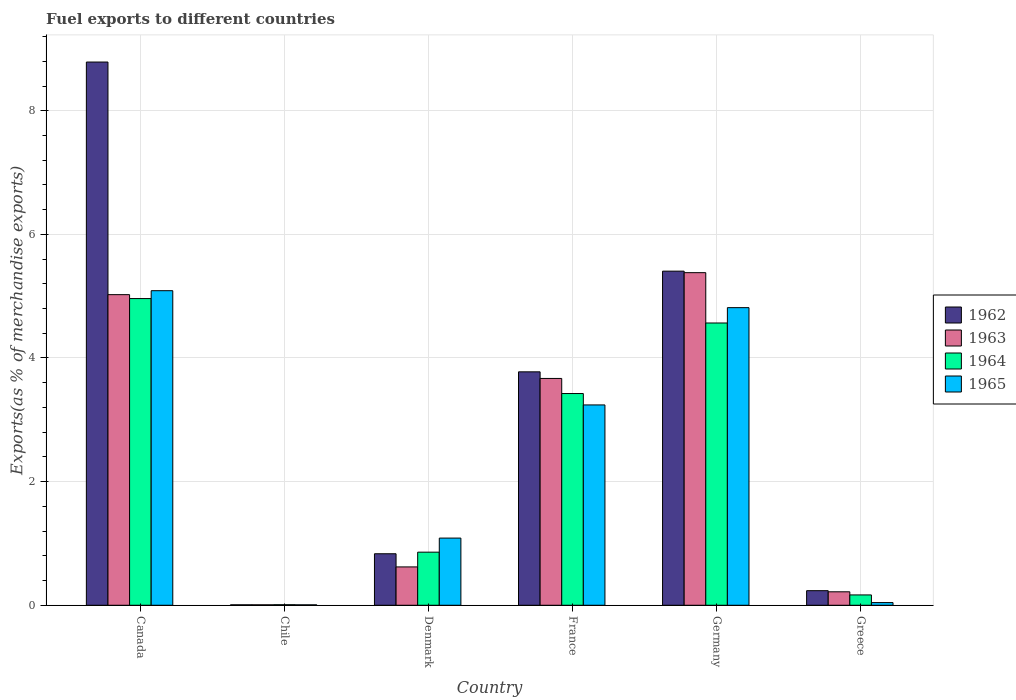How many groups of bars are there?
Keep it short and to the point. 6. Are the number of bars per tick equal to the number of legend labels?
Ensure brevity in your answer.  Yes. How many bars are there on the 1st tick from the left?
Provide a short and direct response. 4. What is the label of the 4th group of bars from the left?
Keep it short and to the point. France. In how many cases, is the number of bars for a given country not equal to the number of legend labels?
Your response must be concise. 0. What is the percentage of exports to different countries in 1965 in France?
Your answer should be compact. 3.24. Across all countries, what is the maximum percentage of exports to different countries in 1965?
Make the answer very short. 5.09. Across all countries, what is the minimum percentage of exports to different countries in 1963?
Offer a very short reply. 0.01. What is the total percentage of exports to different countries in 1964 in the graph?
Make the answer very short. 13.99. What is the difference between the percentage of exports to different countries in 1962 in Chile and that in Denmark?
Make the answer very short. -0.83. What is the difference between the percentage of exports to different countries in 1963 in Greece and the percentage of exports to different countries in 1965 in France?
Provide a succinct answer. -3.02. What is the average percentage of exports to different countries in 1965 per country?
Make the answer very short. 2.38. What is the difference between the percentage of exports to different countries of/in 1963 and percentage of exports to different countries of/in 1965 in Germany?
Make the answer very short. 0.57. In how many countries, is the percentage of exports to different countries in 1964 greater than 4.8 %?
Keep it short and to the point. 1. What is the ratio of the percentage of exports to different countries in 1964 in Canada to that in Chile?
Provide a succinct answer. 555.45. Is the percentage of exports to different countries in 1962 in Canada less than that in Chile?
Make the answer very short. No. Is the difference between the percentage of exports to different countries in 1963 in France and Germany greater than the difference between the percentage of exports to different countries in 1965 in France and Germany?
Make the answer very short. No. What is the difference between the highest and the second highest percentage of exports to different countries in 1962?
Give a very brief answer. 5.01. What is the difference between the highest and the lowest percentage of exports to different countries in 1965?
Keep it short and to the point. 5.08. What does the 4th bar from the left in Chile represents?
Ensure brevity in your answer.  1965. What does the 3rd bar from the right in Greece represents?
Offer a very short reply. 1963. Is it the case that in every country, the sum of the percentage of exports to different countries in 1962 and percentage of exports to different countries in 1964 is greater than the percentage of exports to different countries in 1963?
Offer a very short reply. Yes. How many bars are there?
Provide a short and direct response. 24. Are all the bars in the graph horizontal?
Give a very brief answer. No. How many countries are there in the graph?
Provide a short and direct response. 6. What is the difference between two consecutive major ticks on the Y-axis?
Ensure brevity in your answer.  2. Does the graph contain any zero values?
Give a very brief answer. No. Where does the legend appear in the graph?
Provide a succinct answer. Center right. How are the legend labels stacked?
Keep it short and to the point. Vertical. What is the title of the graph?
Offer a terse response. Fuel exports to different countries. Does "1997" appear as one of the legend labels in the graph?
Ensure brevity in your answer.  No. What is the label or title of the Y-axis?
Offer a terse response. Exports(as % of merchandise exports). What is the Exports(as % of merchandise exports) of 1962 in Canada?
Provide a succinct answer. 8.79. What is the Exports(as % of merchandise exports) of 1963 in Canada?
Your answer should be compact. 5.02. What is the Exports(as % of merchandise exports) of 1964 in Canada?
Ensure brevity in your answer.  4.96. What is the Exports(as % of merchandise exports) of 1965 in Canada?
Make the answer very short. 5.09. What is the Exports(as % of merchandise exports) of 1962 in Chile?
Your answer should be compact. 0.01. What is the Exports(as % of merchandise exports) of 1963 in Chile?
Offer a terse response. 0.01. What is the Exports(as % of merchandise exports) in 1964 in Chile?
Your answer should be very brief. 0.01. What is the Exports(as % of merchandise exports) in 1965 in Chile?
Your response must be concise. 0.01. What is the Exports(as % of merchandise exports) of 1962 in Denmark?
Your answer should be compact. 0.83. What is the Exports(as % of merchandise exports) of 1963 in Denmark?
Give a very brief answer. 0.62. What is the Exports(as % of merchandise exports) in 1964 in Denmark?
Make the answer very short. 0.86. What is the Exports(as % of merchandise exports) of 1965 in Denmark?
Your answer should be very brief. 1.09. What is the Exports(as % of merchandise exports) in 1962 in France?
Keep it short and to the point. 3.78. What is the Exports(as % of merchandise exports) of 1963 in France?
Your answer should be very brief. 3.67. What is the Exports(as % of merchandise exports) of 1964 in France?
Offer a very short reply. 3.43. What is the Exports(as % of merchandise exports) of 1965 in France?
Offer a terse response. 3.24. What is the Exports(as % of merchandise exports) in 1962 in Germany?
Your response must be concise. 5.4. What is the Exports(as % of merchandise exports) of 1963 in Germany?
Your response must be concise. 5.38. What is the Exports(as % of merchandise exports) of 1964 in Germany?
Your response must be concise. 4.57. What is the Exports(as % of merchandise exports) in 1965 in Germany?
Offer a terse response. 4.81. What is the Exports(as % of merchandise exports) of 1962 in Greece?
Offer a very short reply. 0.24. What is the Exports(as % of merchandise exports) of 1963 in Greece?
Your response must be concise. 0.22. What is the Exports(as % of merchandise exports) in 1964 in Greece?
Your answer should be compact. 0.17. What is the Exports(as % of merchandise exports) in 1965 in Greece?
Ensure brevity in your answer.  0.04. Across all countries, what is the maximum Exports(as % of merchandise exports) in 1962?
Offer a very short reply. 8.79. Across all countries, what is the maximum Exports(as % of merchandise exports) of 1963?
Your response must be concise. 5.38. Across all countries, what is the maximum Exports(as % of merchandise exports) of 1964?
Offer a very short reply. 4.96. Across all countries, what is the maximum Exports(as % of merchandise exports) of 1965?
Provide a succinct answer. 5.09. Across all countries, what is the minimum Exports(as % of merchandise exports) of 1962?
Provide a succinct answer. 0.01. Across all countries, what is the minimum Exports(as % of merchandise exports) of 1963?
Provide a succinct answer. 0.01. Across all countries, what is the minimum Exports(as % of merchandise exports) in 1964?
Ensure brevity in your answer.  0.01. Across all countries, what is the minimum Exports(as % of merchandise exports) of 1965?
Offer a terse response. 0.01. What is the total Exports(as % of merchandise exports) in 1962 in the graph?
Ensure brevity in your answer.  19.05. What is the total Exports(as % of merchandise exports) of 1963 in the graph?
Keep it short and to the point. 14.92. What is the total Exports(as % of merchandise exports) of 1964 in the graph?
Give a very brief answer. 13.99. What is the total Exports(as % of merchandise exports) of 1965 in the graph?
Offer a very short reply. 14.28. What is the difference between the Exports(as % of merchandise exports) in 1962 in Canada and that in Chile?
Your answer should be compact. 8.78. What is the difference between the Exports(as % of merchandise exports) of 1963 in Canada and that in Chile?
Your response must be concise. 5.02. What is the difference between the Exports(as % of merchandise exports) of 1964 in Canada and that in Chile?
Keep it short and to the point. 4.95. What is the difference between the Exports(as % of merchandise exports) in 1965 in Canada and that in Chile?
Offer a very short reply. 5.08. What is the difference between the Exports(as % of merchandise exports) of 1962 in Canada and that in Denmark?
Keep it short and to the point. 7.95. What is the difference between the Exports(as % of merchandise exports) of 1963 in Canada and that in Denmark?
Provide a short and direct response. 4.4. What is the difference between the Exports(as % of merchandise exports) of 1964 in Canada and that in Denmark?
Offer a terse response. 4.1. What is the difference between the Exports(as % of merchandise exports) in 1965 in Canada and that in Denmark?
Your answer should be very brief. 4. What is the difference between the Exports(as % of merchandise exports) in 1962 in Canada and that in France?
Offer a very short reply. 5.01. What is the difference between the Exports(as % of merchandise exports) in 1963 in Canada and that in France?
Your answer should be very brief. 1.36. What is the difference between the Exports(as % of merchandise exports) in 1964 in Canada and that in France?
Provide a succinct answer. 1.54. What is the difference between the Exports(as % of merchandise exports) of 1965 in Canada and that in France?
Provide a succinct answer. 1.85. What is the difference between the Exports(as % of merchandise exports) of 1962 in Canada and that in Germany?
Provide a succinct answer. 3.38. What is the difference between the Exports(as % of merchandise exports) of 1963 in Canada and that in Germany?
Your answer should be compact. -0.36. What is the difference between the Exports(as % of merchandise exports) of 1964 in Canada and that in Germany?
Your response must be concise. 0.4. What is the difference between the Exports(as % of merchandise exports) in 1965 in Canada and that in Germany?
Provide a succinct answer. 0.27. What is the difference between the Exports(as % of merchandise exports) of 1962 in Canada and that in Greece?
Provide a short and direct response. 8.55. What is the difference between the Exports(as % of merchandise exports) in 1963 in Canada and that in Greece?
Keep it short and to the point. 4.81. What is the difference between the Exports(as % of merchandise exports) of 1964 in Canada and that in Greece?
Offer a very short reply. 4.79. What is the difference between the Exports(as % of merchandise exports) in 1965 in Canada and that in Greece?
Your response must be concise. 5.05. What is the difference between the Exports(as % of merchandise exports) in 1962 in Chile and that in Denmark?
Make the answer very short. -0.83. What is the difference between the Exports(as % of merchandise exports) in 1963 in Chile and that in Denmark?
Provide a succinct answer. -0.61. What is the difference between the Exports(as % of merchandise exports) of 1964 in Chile and that in Denmark?
Your response must be concise. -0.85. What is the difference between the Exports(as % of merchandise exports) in 1965 in Chile and that in Denmark?
Ensure brevity in your answer.  -1.08. What is the difference between the Exports(as % of merchandise exports) of 1962 in Chile and that in France?
Your answer should be compact. -3.77. What is the difference between the Exports(as % of merchandise exports) of 1963 in Chile and that in France?
Offer a very short reply. -3.66. What is the difference between the Exports(as % of merchandise exports) of 1964 in Chile and that in France?
Provide a short and direct response. -3.42. What is the difference between the Exports(as % of merchandise exports) of 1965 in Chile and that in France?
Provide a short and direct response. -3.23. What is the difference between the Exports(as % of merchandise exports) of 1962 in Chile and that in Germany?
Offer a terse response. -5.4. What is the difference between the Exports(as % of merchandise exports) in 1963 in Chile and that in Germany?
Your response must be concise. -5.37. What is the difference between the Exports(as % of merchandise exports) in 1964 in Chile and that in Germany?
Offer a very short reply. -4.56. What is the difference between the Exports(as % of merchandise exports) in 1965 in Chile and that in Germany?
Ensure brevity in your answer.  -4.81. What is the difference between the Exports(as % of merchandise exports) in 1962 in Chile and that in Greece?
Give a very brief answer. -0.23. What is the difference between the Exports(as % of merchandise exports) in 1963 in Chile and that in Greece?
Offer a terse response. -0.21. What is the difference between the Exports(as % of merchandise exports) of 1964 in Chile and that in Greece?
Keep it short and to the point. -0.16. What is the difference between the Exports(as % of merchandise exports) of 1965 in Chile and that in Greece?
Give a very brief answer. -0.04. What is the difference between the Exports(as % of merchandise exports) of 1962 in Denmark and that in France?
Offer a terse response. -2.94. What is the difference between the Exports(as % of merchandise exports) of 1963 in Denmark and that in France?
Provide a succinct answer. -3.05. What is the difference between the Exports(as % of merchandise exports) of 1964 in Denmark and that in France?
Provide a short and direct response. -2.57. What is the difference between the Exports(as % of merchandise exports) in 1965 in Denmark and that in France?
Offer a terse response. -2.15. What is the difference between the Exports(as % of merchandise exports) in 1962 in Denmark and that in Germany?
Make the answer very short. -4.57. What is the difference between the Exports(as % of merchandise exports) in 1963 in Denmark and that in Germany?
Keep it short and to the point. -4.76. What is the difference between the Exports(as % of merchandise exports) of 1964 in Denmark and that in Germany?
Make the answer very short. -3.71. What is the difference between the Exports(as % of merchandise exports) of 1965 in Denmark and that in Germany?
Your answer should be compact. -3.73. What is the difference between the Exports(as % of merchandise exports) in 1962 in Denmark and that in Greece?
Your response must be concise. 0.6. What is the difference between the Exports(as % of merchandise exports) of 1963 in Denmark and that in Greece?
Give a very brief answer. 0.4. What is the difference between the Exports(as % of merchandise exports) of 1964 in Denmark and that in Greece?
Your answer should be very brief. 0.69. What is the difference between the Exports(as % of merchandise exports) in 1965 in Denmark and that in Greece?
Keep it short and to the point. 1.04. What is the difference between the Exports(as % of merchandise exports) of 1962 in France and that in Germany?
Keep it short and to the point. -1.63. What is the difference between the Exports(as % of merchandise exports) of 1963 in France and that in Germany?
Give a very brief answer. -1.71. What is the difference between the Exports(as % of merchandise exports) in 1964 in France and that in Germany?
Your answer should be very brief. -1.14. What is the difference between the Exports(as % of merchandise exports) in 1965 in France and that in Germany?
Keep it short and to the point. -1.57. What is the difference between the Exports(as % of merchandise exports) in 1962 in France and that in Greece?
Your answer should be compact. 3.54. What is the difference between the Exports(as % of merchandise exports) in 1963 in France and that in Greece?
Your answer should be compact. 3.45. What is the difference between the Exports(as % of merchandise exports) in 1964 in France and that in Greece?
Provide a succinct answer. 3.26. What is the difference between the Exports(as % of merchandise exports) of 1965 in France and that in Greece?
Provide a succinct answer. 3.2. What is the difference between the Exports(as % of merchandise exports) in 1962 in Germany and that in Greece?
Provide a succinct answer. 5.17. What is the difference between the Exports(as % of merchandise exports) in 1963 in Germany and that in Greece?
Give a very brief answer. 5.16. What is the difference between the Exports(as % of merchandise exports) in 1964 in Germany and that in Greece?
Make the answer very short. 4.4. What is the difference between the Exports(as % of merchandise exports) of 1965 in Germany and that in Greece?
Your response must be concise. 4.77. What is the difference between the Exports(as % of merchandise exports) in 1962 in Canada and the Exports(as % of merchandise exports) in 1963 in Chile?
Offer a terse response. 8.78. What is the difference between the Exports(as % of merchandise exports) of 1962 in Canada and the Exports(as % of merchandise exports) of 1964 in Chile?
Your answer should be compact. 8.78. What is the difference between the Exports(as % of merchandise exports) in 1962 in Canada and the Exports(as % of merchandise exports) in 1965 in Chile?
Offer a terse response. 8.78. What is the difference between the Exports(as % of merchandise exports) in 1963 in Canada and the Exports(as % of merchandise exports) in 1964 in Chile?
Provide a succinct answer. 5.02. What is the difference between the Exports(as % of merchandise exports) in 1963 in Canada and the Exports(as % of merchandise exports) in 1965 in Chile?
Give a very brief answer. 5.02. What is the difference between the Exports(as % of merchandise exports) of 1964 in Canada and the Exports(as % of merchandise exports) of 1965 in Chile?
Provide a succinct answer. 4.95. What is the difference between the Exports(as % of merchandise exports) in 1962 in Canada and the Exports(as % of merchandise exports) in 1963 in Denmark?
Ensure brevity in your answer.  8.17. What is the difference between the Exports(as % of merchandise exports) of 1962 in Canada and the Exports(as % of merchandise exports) of 1964 in Denmark?
Your response must be concise. 7.93. What is the difference between the Exports(as % of merchandise exports) of 1962 in Canada and the Exports(as % of merchandise exports) of 1965 in Denmark?
Your response must be concise. 7.7. What is the difference between the Exports(as % of merchandise exports) in 1963 in Canada and the Exports(as % of merchandise exports) in 1964 in Denmark?
Provide a short and direct response. 4.17. What is the difference between the Exports(as % of merchandise exports) in 1963 in Canada and the Exports(as % of merchandise exports) in 1965 in Denmark?
Provide a short and direct response. 3.94. What is the difference between the Exports(as % of merchandise exports) in 1964 in Canada and the Exports(as % of merchandise exports) in 1965 in Denmark?
Ensure brevity in your answer.  3.87. What is the difference between the Exports(as % of merchandise exports) in 1962 in Canada and the Exports(as % of merchandise exports) in 1963 in France?
Offer a terse response. 5.12. What is the difference between the Exports(as % of merchandise exports) in 1962 in Canada and the Exports(as % of merchandise exports) in 1964 in France?
Offer a terse response. 5.36. What is the difference between the Exports(as % of merchandise exports) of 1962 in Canada and the Exports(as % of merchandise exports) of 1965 in France?
Offer a very short reply. 5.55. What is the difference between the Exports(as % of merchandise exports) of 1963 in Canada and the Exports(as % of merchandise exports) of 1964 in France?
Provide a short and direct response. 1.6. What is the difference between the Exports(as % of merchandise exports) of 1963 in Canada and the Exports(as % of merchandise exports) of 1965 in France?
Provide a short and direct response. 1.78. What is the difference between the Exports(as % of merchandise exports) in 1964 in Canada and the Exports(as % of merchandise exports) in 1965 in France?
Ensure brevity in your answer.  1.72. What is the difference between the Exports(as % of merchandise exports) of 1962 in Canada and the Exports(as % of merchandise exports) of 1963 in Germany?
Offer a very short reply. 3.41. What is the difference between the Exports(as % of merchandise exports) of 1962 in Canada and the Exports(as % of merchandise exports) of 1964 in Germany?
Provide a short and direct response. 4.22. What is the difference between the Exports(as % of merchandise exports) in 1962 in Canada and the Exports(as % of merchandise exports) in 1965 in Germany?
Your answer should be very brief. 3.97. What is the difference between the Exports(as % of merchandise exports) of 1963 in Canada and the Exports(as % of merchandise exports) of 1964 in Germany?
Ensure brevity in your answer.  0.46. What is the difference between the Exports(as % of merchandise exports) of 1963 in Canada and the Exports(as % of merchandise exports) of 1965 in Germany?
Offer a very short reply. 0.21. What is the difference between the Exports(as % of merchandise exports) in 1964 in Canada and the Exports(as % of merchandise exports) in 1965 in Germany?
Give a very brief answer. 0.15. What is the difference between the Exports(as % of merchandise exports) of 1962 in Canada and the Exports(as % of merchandise exports) of 1963 in Greece?
Provide a short and direct response. 8.57. What is the difference between the Exports(as % of merchandise exports) of 1962 in Canada and the Exports(as % of merchandise exports) of 1964 in Greece?
Offer a terse response. 8.62. What is the difference between the Exports(as % of merchandise exports) in 1962 in Canada and the Exports(as % of merchandise exports) in 1965 in Greece?
Give a very brief answer. 8.74. What is the difference between the Exports(as % of merchandise exports) in 1963 in Canada and the Exports(as % of merchandise exports) in 1964 in Greece?
Offer a very short reply. 4.86. What is the difference between the Exports(as % of merchandise exports) in 1963 in Canada and the Exports(as % of merchandise exports) in 1965 in Greece?
Your answer should be very brief. 4.98. What is the difference between the Exports(as % of merchandise exports) of 1964 in Canada and the Exports(as % of merchandise exports) of 1965 in Greece?
Give a very brief answer. 4.92. What is the difference between the Exports(as % of merchandise exports) of 1962 in Chile and the Exports(as % of merchandise exports) of 1963 in Denmark?
Your answer should be compact. -0.61. What is the difference between the Exports(as % of merchandise exports) of 1962 in Chile and the Exports(as % of merchandise exports) of 1964 in Denmark?
Offer a terse response. -0.85. What is the difference between the Exports(as % of merchandise exports) in 1962 in Chile and the Exports(as % of merchandise exports) in 1965 in Denmark?
Your answer should be compact. -1.08. What is the difference between the Exports(as % of merchandise exports) of 1963 in Chile and the Exports(as % of merchandise exports) of 1964 in Denmark?
Provide a succinct answer. -0.85. What is the difference between the Exports(as % of merchandise exports) in 1963 in Chile and the Exports(as % of merchandise exports) in 1965 in Denmark?
Ensure brevity in your answer.  -1.08. What is the difference between the Exports(as % of merchandise exports) in 1964 in Chile and the Exports(as % of merchandise exports) in 1965 in Denmark?
Provide a succinct answer. -1.08. What is the difference between the Exports(as % of merchandise exports) of 1962 in Chile and the Exports(as % of merchandise exports) of 1963 in France?
Your response must be concise. -3.66. What is the difference between the Exports(as % of merchandise exports) in 1962 in Chile and the Exports(as % of merchandise exports) in 1964 in France?
Ensure brevity in your answer.  -3.42. What is the difference between the Exports(as % of merchandise exports) in 1962 in Chile and the Exports(as % of merchandise exports) in 1965 in France?
Your response must be concise. -3.23. What is the difference between the Exports(as % of merchandise exports) in 1963 in Chile and the Exports(as % of merchandise exports) in 1964 in France?
Your answer should be very brief. -3.42. What is the difference between the Exports(as % of merchandise exports) of 1963 in Chile and the Exports(as % of merchandise exports) of 1965 in France?
Offer a very short reply. -3.23. What is the difference between the Exports(as % of merchandise exports) of 1964 in Chile and the Exports(as % of merchandise exports) of 1965 in France?
Provide a short and direct response. -3.23. What is the difference between the Exports(as % of merchandise exports) in 1962 in Chile and the Exports(as % of merchandise exports) in 1963 in Germany?
Make the answer very short. -5.37. What is the difference between the Exports(as % of merchandise exports) of 1962 in Chile and the Exports(as % of merchandise exports) of 1964 in Germany?
Ensure brevity in your answer.  -4.56. What is the difference between the Exports(as % of merchandise exports) in 1962 in Chile and the Exports(as % of merchandise exports) in 1965 in Germany?
Make the answer very short. -4.81. What is the difference between the Exports(as % of merchandise exports) of 1963 in Chile and the Exports(as % of merchandise exports) of 1964 in Germany?
Ensure brevity in your answer.  -4.56. What is the difference between the Exports(as % of merchandise exports) in 1963 in Chile and the Exports(as % of merchandise exports) in 1965 in Germany?
Provide a short and direct response. -4.81. What is the difference between the Exports(as % of merchandise exports) of 1964 in Chile and the Exports(as % of merchandise exports) of 1965 in Germany?
Give a very brief answer. -4.81. What is the difference between the Exports(as % of merchandise exports) of 1962 in Chile and the Exports(as % of merchandise exports) of 1963 in Greece?
Provide a short and direct response. -0.21. What is the difference between the Exports(as % of merchandise exports) in 1962 in Chile and the Exports(as % of merchandise exports) in 1964 in Greece?
Provide a short and direct response. -0.16. What is the difference between the Exports(as % of merchandise exports) in 1962 in Chile and the Exports(as % of merchandise exports) in 1965 in Greece?
Give a very brief answer. -0.04. What is the difference between the Exports(as % of merchandise exports) in 1963 in Chile and the Exports(as % of merchandise exports) in 1964 in Greece?
Provide a succinct answer. -0.16. What is the difference between the Exports(as % of merchandise exports) in 1963 in Chile and the Exports(as % of merchandise exports) in 1965 in Greece?
Keep it short and to the point. -0.04. What is the difference between the Exports(as % of merchandise exports) of 1964 in Chile and the Exports(as % of merchandise exports) of 1965 in Greece?
Provide a short and direct response. -0.03. What is the difference between the Exports(as % of merchandise exports) in 1962 in Denmark and the Exports(as % of merchandise exports) in 1963 in France?
Keep it short and to the point. -2.84. What is the difference between the Exports(as % of merchandise exports) in 1962 in Denmark and the Exports(as % of merchandise exports) in 1964 in France?
Give a very brief answer. -2.59. What is the difference between the Exports(as % of merchandise exports) in 1962 in Denmark and the Exports(as % of merchandise exports) in 1965 in France?
Provide a succinct answer. -2.41. What is the difference between the Exports(as % of merchandise exports) of 1963 in Denmark and the Exports(as % of merchandise exports) of 1964 in France?
Offer a terse response. -2.8. What is the difference between the Exports(as % of merchandise exports) of 1963 in Denmark and the Exports(as % of merchandise exports) of 1965 in France?
Your answer should be compact. -2.62. What is the difference between the Exports(as % of merchandise exports) of 1964 in Denmark and the Exports(as % of merchandise exports) of 1965 in France?
Give a very brief answer. -2.38. What is the difference between the Exports(as % of merchandise exports) of 1962 in Denmark and the Exports(as % of merchandise exports) of 1963 in Germany?
Keep it short and to the point. -4.55. What is the difference between the Exports(as % of merchandise exports) of 1962 in Denmark and the Exports(as % of merchandise exports) of 1964 in Germany?
Your answer should be compact. -3.73. What is the difference between the Exports(as % of merchandise exports) in 1962 in Denmark and the Exports(as % of merchandise exports) in 1965 in Germany?
Your answer should be very brief. -3.98. What is the difference between the Exports(as % of merchandise exports) of 1963 in Denmark and the Exports(as % of merchandise exports) of 1964 in Germany?
Give a very brief answer. -3.95. What is the difference between the Exports(as % of merchandise exports) in 1963 in Denmark and the Exports(as % of merchandise exports) in 1965 in Germany?
Ensure brevity in your answer.  -4.19. What is the difference between the Exports(as % of merchandise exports) in 1964 in Denmark and the Exports(as % of merchandise exports) in 1965 in Germany?
Give a very brief answer. -3.96. What is the difference between the Exports(as % of merchandise exports) of 1962 in Denmark and the Exports(as % of merchandise exports) of 1963 in Greece?
Keep it short and to the point. 0.62. What is the difference between the Exports(as % of merchandise exports) in 1962 in Denmark and the Exports(as % of merchandise exports) in 1964 in Greece?
Your answer should be compact. 0.67. What is the difference between the Exports(as % of merchandise exports) in 1962 in Denmark and the Exports(as % of merchandise exports) in 1965 in Greece?
Ensure brevity in your answer.  0.79. What is the difference between the Exports(as % of merchandise exports) of 1963 in Denmark and the Exports(as % of merchandise exports) of 1964 in Greece?
Ensure brevity in your answer.  0.45. What is the difference between the Exports(as % of merchandise exports) in 1963 in Denmark and the Exports(as % of merchandise exports) in 1965 in Greece?
Make the answer very short. 0.58. What is the difference between the Exports(as % of merchandise exports) of 1964 in Denmark and the Exports(as % of merchandise exports) of 1965 in Greece?
Your answer should be compact. 0.82. What is the difference between the Exports(as % of merchandise exports) of 1962 in France and the Exports(as % of merchandise exports) of 1963 in Germany?
Provide a succinct answer. -1.6. What is the difference between the Exports(as % of merchandise exports) of 1962 in France and the Exports(as % of merchandise exports) of 1964 in Germany?
Make the answer very short. -0.79. What is the difference between the Exports(as % of merchandise exports) in 1962 in France and the Exports(as % of merchandise exports) in 1965 in Germany?
Provide a succinct answer. -1.04. What is the difference between the Exports(as % of merchandise exports) of 1963 in France and the Exports(as % of merchandise exports) of 1964 in Germany?
Offer a terse response. -0.9. What is the difference between the Exports(as % of merchandise exports) of 1963 in France and the Exports(as % of merchandise exports) of 1965 in Germany?
Provide a short and direct response. -1.15. What is the difference between the Exports(as % of merchandise exports) in 1964 in France and the Exports(as % of merchandise exports) in 1965 in Germany?
Give a very brief answer. -1.39. What is the difference between the Exports(as % of merchandise exports) of 1962 in France and the Exports(as % of merchandise exports) of 1963 in Greece?
Your answer should be compact. 3.56. What is the difference between the Exports(as % of merchandise exports) of 1962 in France and the Exports(as % of merchandise exports) of 1964 in Greece?
Offer a terse response. 3.61. What is the difference between the Exports(as % of merchandise exports) of 1962 in France and the Exports(as % of merchandise exports) of 1965 in Greece?
Provide a succinct answer. 3.73. What is the difference between the Exports(as % of merchandise exports) of 1963 in France and the Exports(as % of merchandise exports) of 1964 in Greece?
Provide a succinct answer. 3.5. What is the difference between the Exports(as % of merchandise exports) in 1963 in France and the Exports(as % of merchandise exports) in 1965 in Greece?
Make the answer very short. 3.63. What is the difference between the Exports(as % of merchandise exports) in 1964 in France and the Exports(as % of merchandise exports) in 1965 in Greece?
Provide a short and direct response. 3.38. What is the difference between the Exports(as % of merchandise exports) in 1962 in Germany and the Exports(as % of merchandise exports) in 1963 in Greece?
Your answer should be compact. 5.19. What is the difference between the Exports(as % of merchandise exports) of 1962 in Germany and the Exports(as % of merchandise exports) of 1964 in Greece?
Provide a succinct answer. 5.24. What is the difference between the Exports(as % of merchandise exports) of 1962 in Germany and the Exports(as % of merchandise exports) of 1965 in Greece?
Provide a succinct answer. 5.36. What is the difference between the Exports(as % of merchandise exports) of 1963 in Germany and the Exports(as % of merchandise exports) of 1964 in Greece?
Keep it short and to the point. 5.21. What is the difference between the Exports(as % of merchandise exports) of 1963 in Germany and the Exports(as % of merchandise exports) of 1965 in Greece?
Offer a very short reply. 5.34. What is the difference between the Exports(as % of merchandise exports) of 1964 in Germany and the Exports(as % of merchandise exports) of 1965 in Greece?
Offer a terse response. 4.52. What is the average Exports(as % of merchandise exports) of 1962 per country?
Your answer should be very brief. 3.17. What is the average Exports(as % of merchandise exports) of 1963 per country?
Your response must be concise. 2.49. What is the average Exports(as % of merchandise exports) in 1964 per country?
Your response must be concise. 2.33. What is the average Exports(as % of merchandise exports) of 1965 per country?
Offer a very short reply. 2.38. What is the difference between the Exports(as % of merchandise exports) in 1962 and Exports(as % of merchandise exports) in 1963 in Canada?
Provide a succinct answer. 3.76. What is the difference between the Exports(as % of merchandise exports) of 1962 and Exports(as % of merchandise exports) of 1964 in Canada?
Provide a short and direct response. 3.83. What is the difference between the Exports(as % of merchandise exports) of 1962 and Exports(as % of merchandise exports) of 1965 in Canada?
Make the answer very short. 3.7. What is the difference between the Exports(as % of merchandise exports) of 1963 and Exports(as % of merchandise exports) of 1964 in Canada?
Your response must be concise. 0.06. What is the difference between the Exports(as % of merchandise exports) in 1963 and Exports(as % of merchandise exports) in 1965 in Canada?
Ensure brevity in your answer.  -0.06. What is the difference between the Exports(as % of merchandise exports) in 1964 and Exports(as % of merchandise exports) in 1965 in Canada?
Provide a succinct answer. -0.13. What is the difference between the Exports(as % of merchandise exports) in 1962 and Exports(as % of merchandise exports) in 1963 in Chile?
Give a very brief answer. -0. What is the difference between the Exports(as % of merchandise exports) in 1962 and Exports(as % of merchandise exports) in 1964 in Chile?
Your response must be concise. -0. What is the difference between the Exports(as % of merchandise exports) of 1963 and Exports(as % of merchandise exports) of 1964 in Chile?
Keep it short and to the point. -0. What is the difference between the Exports(as % of merchandise exports) of 1963 and Exports(as % of merchandise exports) of 1965 in Chile?
Your response must be concise. 0. What is the difference between the Exports(as % of merchandise exports) in 1964 and Exports(as % of merchandise exports) in 1965 in Chile?
Offer a very short reply. 0. What is the difference between the Exports(as % of merchandise exports) in 1962 and Exports(as % of merchandise exports) in 1963 in Denmark?
Offer a terse response. 0.21. What is the difference between the Exports(as % of merchandise exports) in 1962 and Exports(as % of merchandise exports) in 1964 in Denmark?
Keep it short and to the point. -0.03. What is the difference between the Exports(as % of merchandise exports) in 1962 and Exports(as % of merchandise exports) in 1965 in Denmark?
Provide a short and direct response. -0.25. What is the difference between the Exports(as % of merchandise exports) in 1963 and Exports(as % of merchandise exports) in 1964 in Denmark?
Offer a very short reply. -0.24. What is the difference between the Exports(as % of merchandise exports) of 1963 and Exports(as % of merchandise exports) of 1965 in Denmark?
Give a very brief answer. -0.47. What is the difference between the Exports(as % of merchandise exports) in 1964 and Exports(as % of merchandise exports) in 1965 in Denmark?
Your answer should be very brief. -0.23. What is the difference between the Exports(as % of merchandise exports) of 1962 and Exports(as % of merchandise exports) of 1963 in France?
Your answer should be very brief. 0.11. What is the difference between the Exports(as % of merchandise exports) of 1962 and Exports(as % of merchandise exports) of 1964 in France?
Your answer should be compact. 0.35. What is the difference between the Exports(as % of merchandise exports) in 1962 and Exports(as % of merchandise exports) in 1965 in France?
Offer a terse response. 0.54. What is the difference between the Exports(as % of merchandise exports) in 1963 and Exports(as % of merchandise exports) in 1964 in France?
Offer a very short reply. 0.24. What is the difference between the Exports(as % of merchandise exports) in 1963 and Exports(as % of merchandise exports) in 1965 in France?
Offer a terse response. 0.43. What is the difference between the Exports(as % of merchandise exports) in 1964 and Exports(as % of merchandise exports) in 1965 in France?
Give a very brief answer. 0.18. What is the difference between the Exports(as % of merchandise exports) of 1962 and Exports(as % of merchandise exports) of 1963 in Germany?
Your response must be concise. 0.02. What is the difference between the Exports(as % of merchandise exports) in 1962 and Exports(as % of merchandise exports) in 1964 in Germany?
Your answer should be very brief. 0.84. What is the difference between the Exports(as % of merchandise exports) in 1962 and Exports(as % of merchandise exports) in 1965 in Germany?
Ensure brevity in your answer.  0.59. What is the difference between the Exports(as % of merchandise exports) of 1963 and Exports(as % of merchandise exports) of 1964 in Germany?
Your answer should be very brief. 0.81. What is the difference between the Exports(as % of merchandise exports) in 1963 and Exports(as % of merchandise exports) in 1965 in Germany?
Offer a terse response. 0.57. What is the difference between the Exports(as % of merchandise exports) of 1964 and Exports(as % of merchandise exports) of 1965 in Germany?
Offer a very short reply. -0.25. What is the difference between the Exports(as % of merchandise exports) in 1962 and Exports(as % of merchandise exports) in 1963 in Greece?
Your answer should be very brief. 0.02. What is the difference between the Exports(as % of merchandise exports) in 1962 and Exports(as % of merchandise exports) in 1964 in Greece?
Provide a short and direct response. 0.07. What is the difference between the Exports(as % of merchandise exports) of 1962 and Exports(as % of merchandise exports) of 1965 in Greece?
Ensure brevity in your answer.  0.19. What is the difference between the Exports(as % of merchandise exports) of 1963 and Exports(as % of merchandise exports) of 1964 in Greece?
Make the answer very short. 0.05. What is the difference between the Exports(as % of merchandise exports) of 1963 and Exports(as % of merchandise exports) of 1965 in Greece?
Provide a short and direct response. 0.17. What is the difference between the Exports(as % of merchandise exports) of 1964 and Exports(as % of merchandise exports) of 1965 in Greece?
Keep it short and to the point. 0.12. What is the ratio of the Exports(as % of merchandise exports) of 1962 in Canada to that in Chile?
Your answer should be compact. 1254.38. What is the ratio of the Exports(as % of merchandise exports) in 1963 in Canada to that in Chile?
Your answer should be compact. 709.22. What is the ratio of the Exports(as % of merchandise exports) of 1964 in Canada to that in Chile?
Your response must be concise. 555.45. What is the ratio of the Exports(as % of merchandise exports) of 1965 in Canada to that in Chile?
Ensure brevity in your answer.  752.83. What is the ratio of the Exports(as % of merchandise exports) of 1962 in Canada to that in Denmark?
Keep it short and to the point. 10.55. What is the ratio of the Exports(as % of merchandise exports) of 1963 in Canada to that in Denmark?
Provide a short and direct response. 8.1. What is the ratio of the Exports(as % of merchandise exports) of 1964 in Canada to that in Denmark?
Offer a terse response. 5.78. What is the ratio of the Exports(as % of merchandise exports) in 1965 in Canada to that in Denmark?
Provide a succinct answer. 4.68. What is the ratio of the Exports(as % of merchandise exports) in 1962 in Canada to that in France?
Offer a terse response. 2.33. What is the ratio of the Exports(as % of merchandise exports) of 1963 in Canada to that in France?
Your answer should be very brief. 1.37. What is the ratio of the Exports(as % of merchandise exports) of 1964 in Canada to that in France?
Your answer should be very brief. 1.45. What is the ratio of the Exports(as % of merchandise exports) in 1965 in Canada to that in France?
Provide a succinct answer. 1.57. What is the ratio of the Exports(as % of merchandise exports) in 1962 in Canada to that in Germany?
Your answer should be compact. 1.63. What is the ratio of the Exports(as % of merchandise exports) in 1963 in Canada to that in Germany?
Provide a succinct answer. 0.93. What is the ratio of the Exports(as % of merchandise exports) in 1964 in Canada to that in Germany?
Your answer should be compact. 1.09. What is the ratio of the Exports(as % of merchandise exports) of 1965 in Canada to that in Germany?
Provide a succinct answer. 1.06. What is the ratio of the Exports(as % of merchandise exports) of 1962 in Canada to that in Greece?
Your answer should be compact. 37.25. What is the ratio of the Exports(as % of merchandise exports) in 1963 in Canada to that in Greece?
Make the answer very short. 23.07. What is the ratio of the Exports(as % of merchandise exports) of 1964 in Canada to that in Greece?
Give a very brief answer. 29.7. What is the ratio of the Exports(as % of merchandise exports) in 1965 in Canada to that in Greece?
Keep it short and to the point. 117.28. What is the ratio of the Exports(as % of merchandise exports) of 1962 in Chile to that in Denmark?
Make the answer very short. 0.01. What is the ratio of the Exports(as % of merchandise exports) in 1963 in Chile to that in Denmark?
Your response must be concise. 0.01. What is the ratio of the Exports(as % of merchandise exports) of 1964 in Chile to that in Denmark?
Your response must be concise. 0.01. What is the ratio of the Exports(as % of merchandise exports) in 1965 in Chile to that in Denmark?
Your answer should be compact. 0.01. What is the ratio of the Exports(as % of merchandise exports) in 1962 in Chile to that in France?
Provide a succinct answer. 0. What is the ratio of the Exports(as % of merchandise exports) of 1963 in Chile to that in France?
Your answer should be compact. 0. What is the ratio of the Exports(as % of merchandise exports) in 1964 in Chile to that in France?
Your answer should be compact. 0. What is the ratio of the Exports(as % of merchandise exports) in 1965 in Chile to that in France?
Your answer should be very brief. 0. What is the ratio of the Exports(as % of merchandise exports) of 1962 in Chile to that in Germany?
Offer a terse response. 0. What is the ratio of the Exports(as % of merchandise exports) in 1963 in Chile to that in Germany?
Offer a terse response. 0. What is the ratio of the Exports(as % of merchandise exports) in 1964 in Chile to that in Germany?
Your answer should be very brief. 0. What is the ratio of the Exports(as % of merchandise exports) in 1965 in Chile to that in Germany?
Your answer should be compact. 0. What is the ratio of the Exports(as % of merchandise exports) in 1962 in Chile to that in Greece?
Offer a terse response. 0.03. What is the ratio of the Exports(as % of merchandise exports) in 1963 in Chile to that in Greece?
Provide a succinct answer. 0.03. What is the ratio of the Exports(as % of merchandise exports) of 1964 in Chile to that in Greece?
Ensure brevity in your answer.  0.05. What is the ratio of the Exports(as % of merchandise exports) in 1965 in Chile to that in Greece?
Your answer should be compact. 0.16. What is the ratio of the Exports(as % of merchandise exports) in 1962 in Denmark to that in France?
Give a very brief answer. 0.22. What is the ratio of the Exports(as % of merchandise exports) of 1963 in Denmark to that in France?
Your answer should be very brief. 0.17. What is the ratio of the Exports(as % of merchandise exports) of 1964 in Denmark to that in France?
Keep it short and to the point. 0.25. What is the ratio of the Exports(as % of merchandise exports) in 1965 in Denmark to that in France?
Provide a succinct answer. 0.34. What is the ratio of the Exports(as % of merchandise exports) of 1962 in Denmark to that in Germany?
Your answer should be very brief. 0.15. What is the ratio of the Exports(as % of merchandise exports) of 1963 in Denmark to that in Germany?
Provide a succinct answer. 0.12. What is the ratio of the Exports(as % of merchandise exports) in 1964 in Denmark to that in Germany?
Offer a terse response. 0.19. What is the ratio of the Exports(as % of merchandise exports) in 1965 in Denmark to that in Germany?
Keep it short and to the point. 0.23. What is the ratio of the Exports(as % of merchandise exports) of 1962 in Denmark to that in Greece?
Offer a very short reply. 3.53. What is the ratio of the Exports(as % of merchandise exports) of 1963 in Denmark to that in Greece?
Your answer should be very brief. 2.85. What is the ratio of the Exports(as % of merchandise exports) of 1964 in Denmark to that in Greece?
Offer a terse response. 5.14. What is the ratio of the Exports(as % of merchandise exports) in 1965 in Denmark to that in Greece?
Provide a short and direct response. 25.05. What is the ratio of the Exports(as % of merchandise exports) of 1962 in France to that in Germany?
Your answer should be very brief. 0.7. What is the ratio of the Exports(as % of merchandise exports) of 1963 in France to that in Germany?
Provide a succinct answer. 0.68. What is the ratio of the Exports(as % of merchandise exports) of 1964 in France to that in Germany?
Provide a succinct answer. 0.75. What is the ratio of the Exports(as % of merchandise exports) in 1965 in France to that in Germany?
Make the answer very short. 0.67. What is the ratio of the Exports(as % of merchandise exports) of 1962 in France to that in Greece?
Provide a short and direct response. 16.01. What is the ratio of the Exports(as % of merchandise exports) in 1963 in France to that in Greece?
Ensure brevity in your answer.  16.85. What is the ratio of the Exports(as % of merchandise exports) of 1964 in France to that in Greece?
Your answer should be very brief. 20.5. What is the ratio of the Exports(as % of merchandise exports) in 1965 in France to that in Greece?
Your response must be concise. 74.69. What is the ratio of the Exports(as % of merchandise exports) of 1962 in Germany to that in Greece?
Offer a terse response. 22.91. What is the ratio of the Exports(as % of merchandise exports) in 1963 in Germany to that in Greece?
Keep it short and to the point. 24.71. What is the ratio of the Exports(as % of merchandise exports) in 1964 in Germany to that in Greece?
Your answer should be very brief. 27.34. What is the ratio of the Exports(as % of merchandise exports) in 1965 in Germany to that in Greece?
Ensure brevity in your answer.  110.96. What is the difference between the highest and the second highest Exports(as % of merchandise exports) in 1962?
Offer a very short reply. 3.38. What is the difference between the highest and the second highest Exports(as % of merchandise exports) in 1963?
Your answer should be compact. 0.36. What is the difference between the highest and the second highest Exports(as % of merchandise exports) in 1964?
Make the answer very short. 0.4. What is the difference between the highest and the second highest Exports(as % of merchandise exports) in 1965?
Ensure brevity in your answer.  0.27. What is the difference between the highest and the lowest Exports(as % of merchandise exports) of 1962?
Give a very brief answer. 8.78. What is the difference between the highest and the lowest Exports(as % of merchandise exports) in 1963?
Ensure brevity in your answer.  5.37. What is the difference between the highest and the lowest Exports(as % of merchandise exports) of 1964?
Provide a succinct answer. 4.95. What is the difference between the highest and the lowest Exports(as % of merchandise exports) of 1965?
Offer a very short reply. 5.08. 